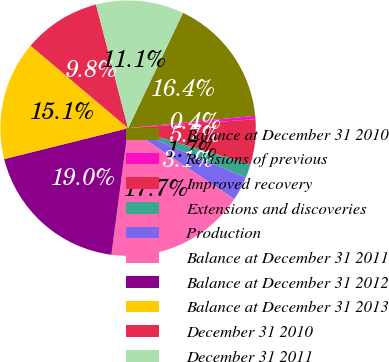<chart> <loc_0><loc_0><loc_500><loc_500><pie_chart><fcel>Balance at December 31 2010<fcel>Revisions of previous<fcel>Improved recovery<fcel>Extensions and discoveries<fcel>Production<fcel>Balance at December 31 2011<fcel>Balance at December 31 2012<fcel>Balance at December 31 2013<fcel>December 31 2010<fcel>December 31 2011<nl><fcel>16.38%<fcel>0.43%<fcel>5.7%<fcel>1.74%<fcel>3.06%<fcel>17.7%<fcel>19.02%<fcel>15.06%<fcel>9.79%<fcel>11.11%<nl></chart> 